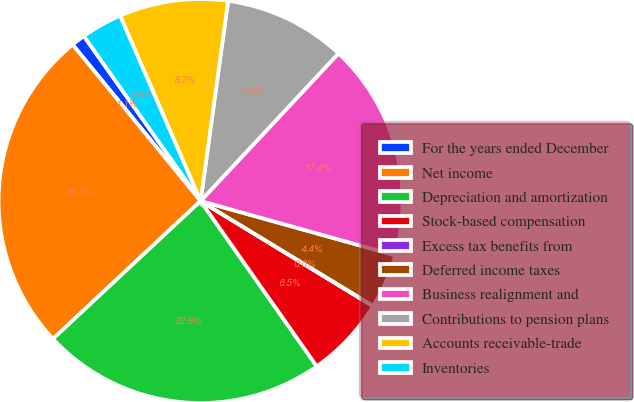Convert chart to OTSL. <chart><loc_0><loc_0><loc_500><loc_500><pie_chart><fcel>For the years ended December<fcel>Net income<fcel>Depreciation and amortization<fcel>Stock-based compensation<fcel>Excess tax benefits from<fcel>Deferred income taxes<fcel>Business realignment and<fcel>Contributions to pension plans<fcel>Accounts receivable-trade<fcel>Inventories<nl><fcel>1.11%<fcel>26.04%<fcel>22.79%<fcel>6.53%<fcel>0.03%<fcel>4.36%<fcel>17.37%<fcel>9.78%<fcel>8.7%<fcel>3.28%<nl></chart> 